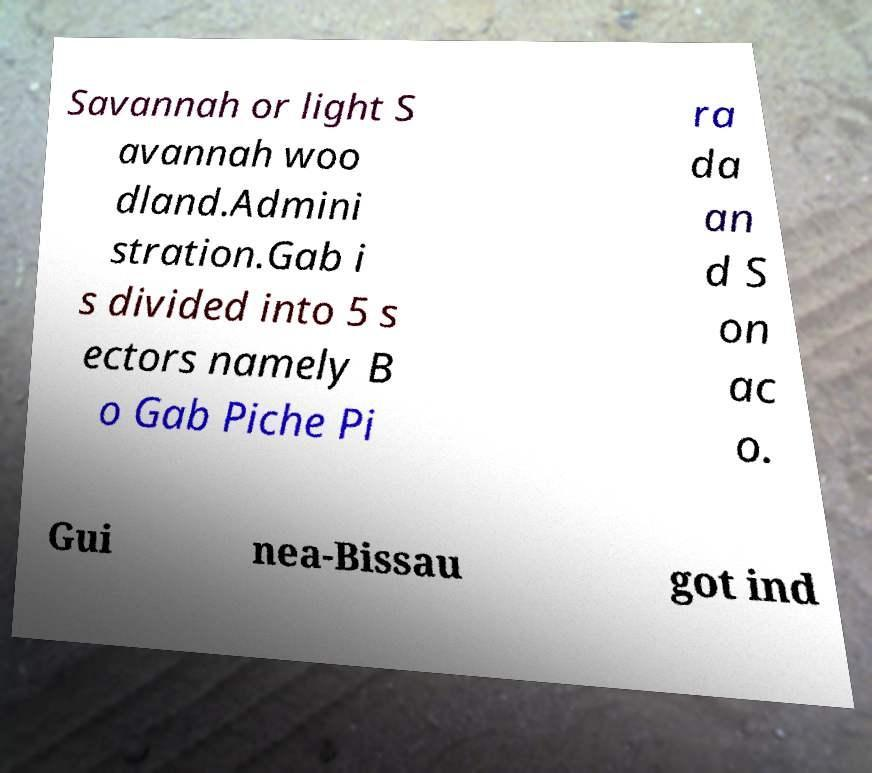There's text embedded in this image that I need extracted. Can you transcribe it verbatim? Savannah or light S avannah woo dland.Admini stration.Gab i s divided into 5 s ectors namely B o Gab Piche Pi ra da an d S on ac o. Gui nea-Bissau got ind 